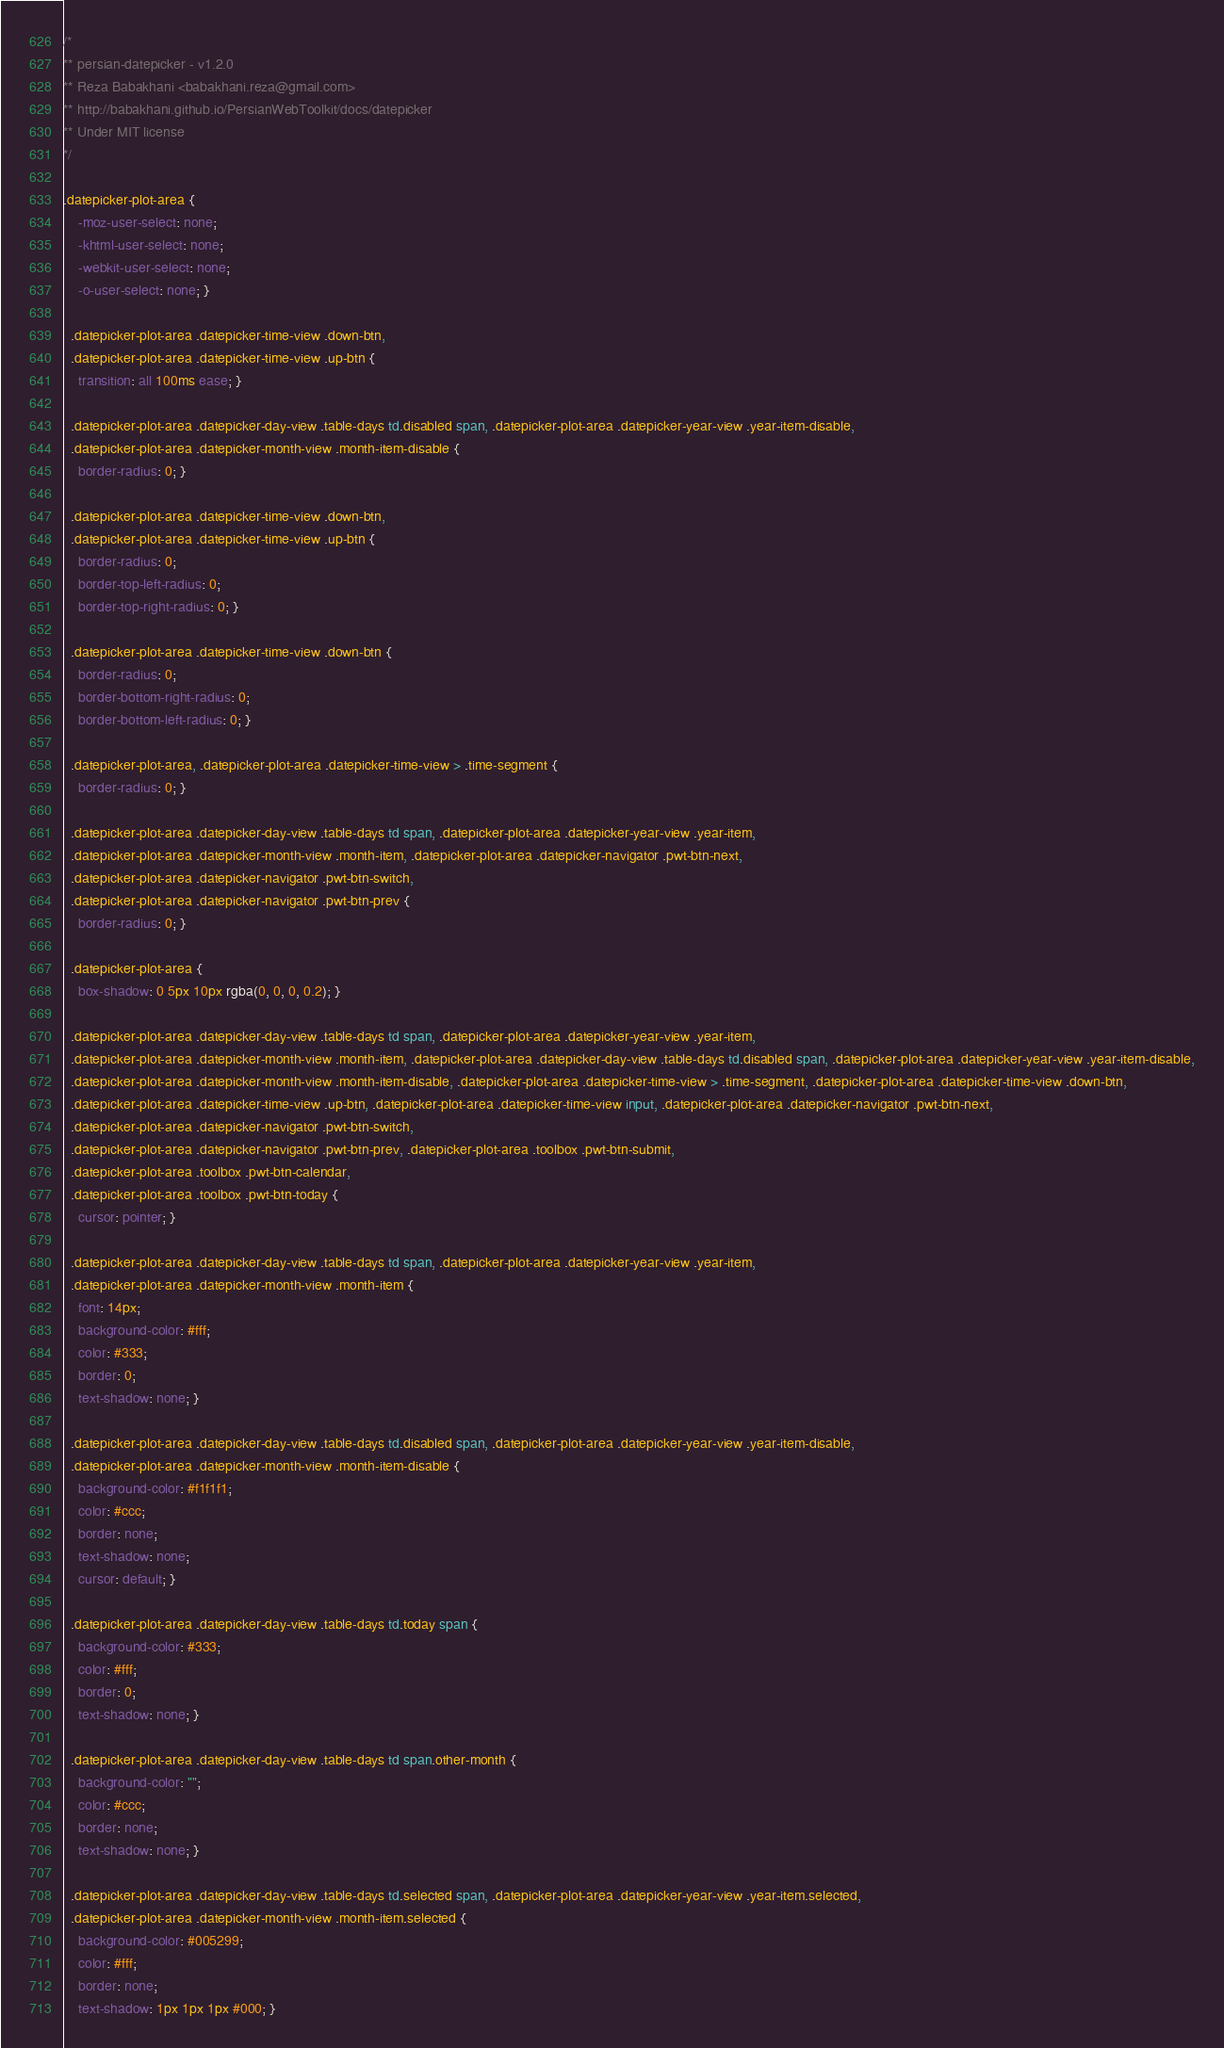Convert code to text. <code><loc_0><loc_0><loc_500><loc_500><_CSS_>/*
** persian-datepicker - v1.2.0
** Reza Babakhani <babakhani.reza@gmail.com>
** http://babakhani.github.io/PersianWebToolkit/docs/datepicker
** Under MIT license
*/

.datepicker-plot-area {
    -moz-user-select: none;
    -khtml-user-select: none;
    -webkit-user-select: none;
    -o-user-select: none; }

  .datepicker-plot-area .datepicker-time-view .down-btn,
  .datepicker-plot-area .datepicker-time-view .up-btn {
    transition: all 100ms ease; }

  .datepicker-plot-area .datepicker-day-view .table-days td.disabled span, .datepicker-plot-area .datepicker-year-view .year-item-disable,
  .datepicker-plot-area .datepicker-month-view .month-item-disable {
    border-radius: 0; }

  .datepicker-plot-area .datepicker-time-view .down-btn,
  .datepicker-plot-area .datepicker-time-view .up-btn {
    border-radius: 0;
    border-top-left-radius: 0;
    border-top-right-radius: 0; }

  .datepicker-plot-area .datepicker-time-view .down-btn {
    border-radius: 0;
    border-bottom-right-radius: 0;
    border-bottom-left-radius: 0; }

  .datepicker-plot-area, .datepicker-plot-area .datepicker-time-view > .time-segment {
    border-radius: 0; }

  .datepicker-plot-area .datepicker-day-view .table-days td span, .datepicker-plot-area .datepicker-year-view .year-item,
  .datepicker-plot-area .datepicker-month-view .month-item, .datepicker-plot-area .datepicker-navigator .pwt-btn-next,
  .datepicker-plot-area .datepicker-navigator .pwt-btn-switch,
  .datepicker-plot-area .datepicker-navigator .pwt-btn-prev {
    border-radius: 0; }

  .datepicker-plot-area {
    box-shadow: 0 5px 10px rgba(0, 0, 0, 0.2); }

  .datepicker-plot-area .datepicker-day-view .table-days td span, .datepicker-plot-area .datepicker-year-view .year-item,
  .datepicker-plot-area .datepicker-month-view .month-item, .datepicker-plot-area .datepicker-day-view .table-days td.disabled span, .datepicker-plot-area .datepicker-year-view .year-item-disable,
  .datepicker-plot-area .datepicker-month-view .month-item-disable, .datepicker-plot-area .datepicker-time-view > .time-segment, .datepicker-plot-area .datepicker-time-view .down-btn,
  .datepicker-plot-area .datepicker-time-view .up-btn, .datepicker-plot-area .datepicker-time-view input, .datepicker-plot-area .datepicker-navigator .pwt-btn-next,
  .datepicker-plot-area .datepicker-navigator .pwt-btn-switch,
  .datepicker-plot-area .datepicker-navigator .pwt-btn-prev, .datepicker-plot-area .toolbox .pwt-btn-submit,
  .datepicker-plot-area .toolbox .pwt-btn-calendar,
  .datepicker-plot-area .toolbox .pwt-btn-today {
    cursor: pointer; }

  .datepicker-plot-area .datepicker-day-view .table-days td span, .datepicker-plot-area .datepicker-year-view .year-item,
  .datepicker-plot-area .datepicker-month-view .month-item {
    font: 14px;
    background-color: #fff;
    color: #333;
    border: 0;
    text-shadow: none; }

  .datepicker-plot-area .datepicker-day-view .table-days td.disabled span, .datepicker-plot-area .datepicker-year-view .year-item-disable,
  .datepicker-plot-area .datepicker-month-view .month-item-disable {
    background-color: #f1f1f1;
    color: #ccc;
    border: none;
    text-shadow: none;
    cursor: default; }

  .datepicker-plot-area .datepicker-day-view .table-days td.today span {
    background-color: #333;
    color: #fff;
    border: 0;
    text-shadow: none; }

  .datepicker-plot-area .datepicker-day-view .table-days td span.other-month {
    background-color: "";
    color: #ccc;
    border: none;
    text-shadow: none; }

  .datepicker-plot-area .datepicker-day-view .table-days td.selected span, .datepicker-plot-area .datepicker-year-view .year-item.selected,
  .datepicker-plot-area .datepicker-month-view .month-item.selected {
    background-color: #005299;
    color: #fff;
    border: none;
    text-shadow: 1px 1px 1px #000; }
</code> 